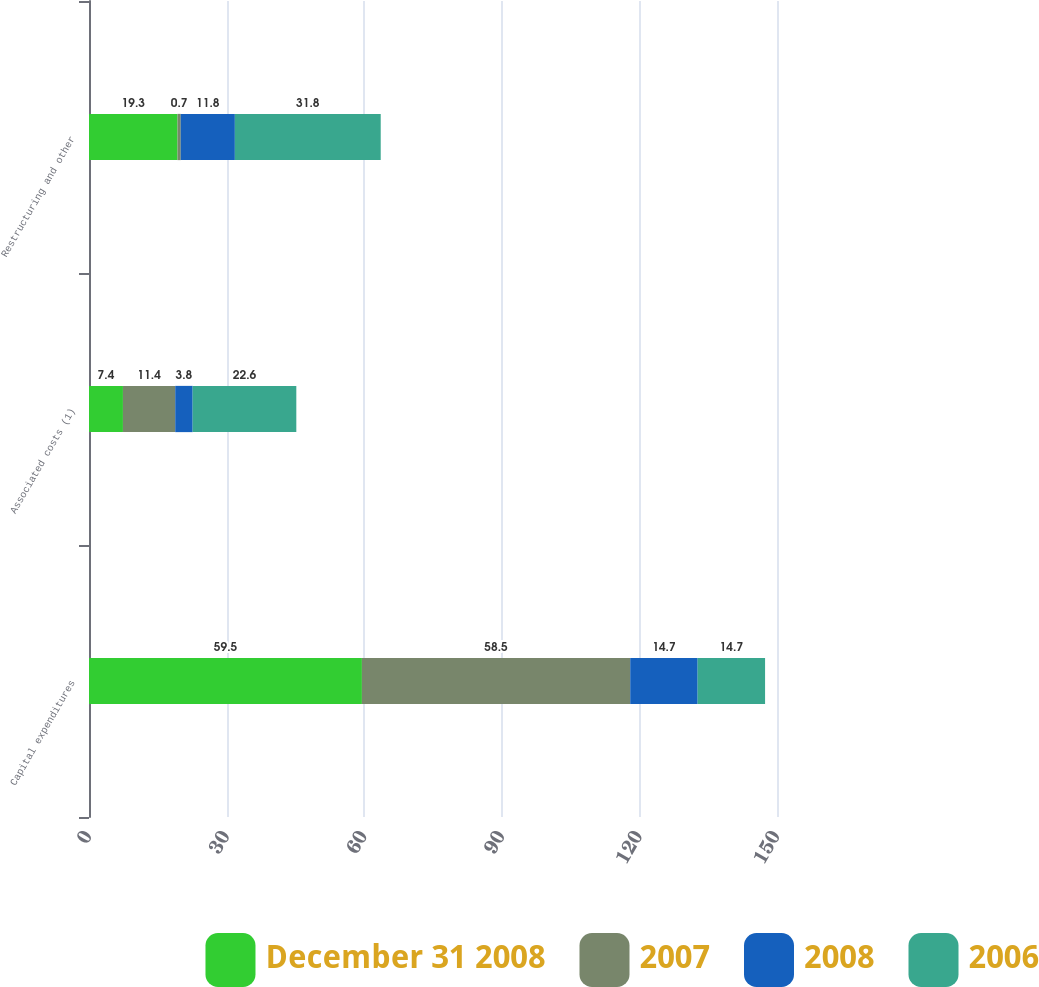Convert chart. <chart><loc_0><loc_0><loc_500><loc_500><stacked_bar_chart><ecel><fcel>Capital expenditures<fcel>Associated costs (1)<fcel>Restructuring and other<nl><fcel>December 31 2008<fcel>59.5<fcel>7.4<fcel>19.3<nl><fcel>2007<fcel>58.5<fcel>11.4<fcel>0.7<nl><fcel>2008<fcel>14.7<fcel>3.8<fcel>11.8<nl><fcel>2006<fcel>14.7<fcel>22.6<fcel>31.8<nl></chart> 